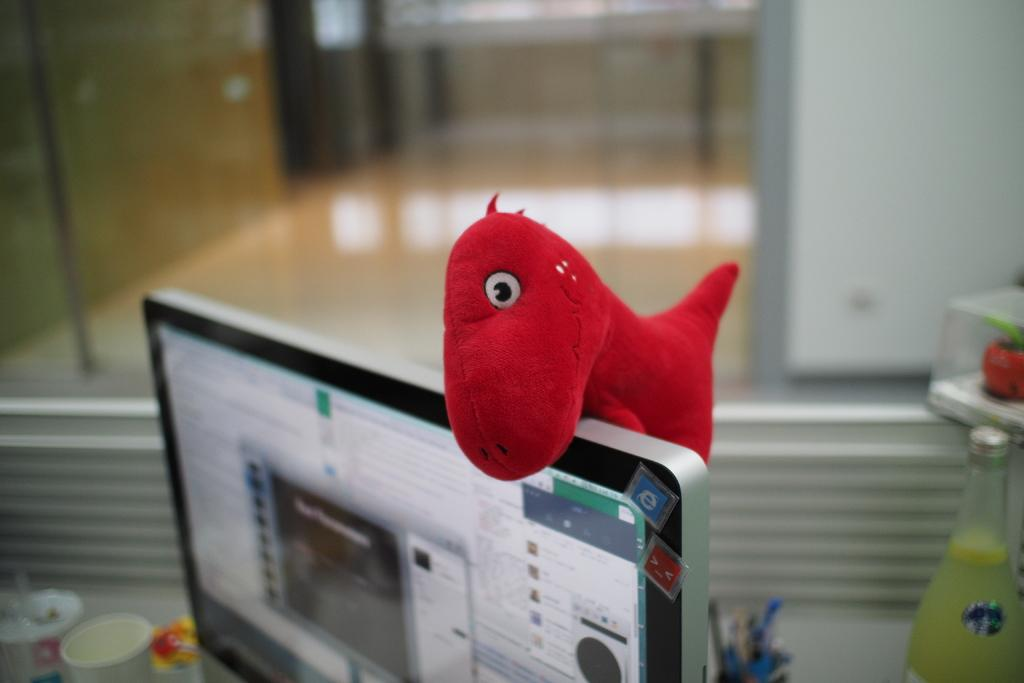What is the main object in the image? There is a screen in the image. What is placed on the screen? A red color toy is on the screen. What type of containers can be seen in the image? There are cups and a bottle in the image. Where are the pens located in the image? The pens are in a holder in the image. Can you describe the background of the image? The background of the image is blurred. How does the flock of birds support the weight of the screen in the image? There is no flock of birds present in the image, and therefore they cannot support the weight of the screen. 